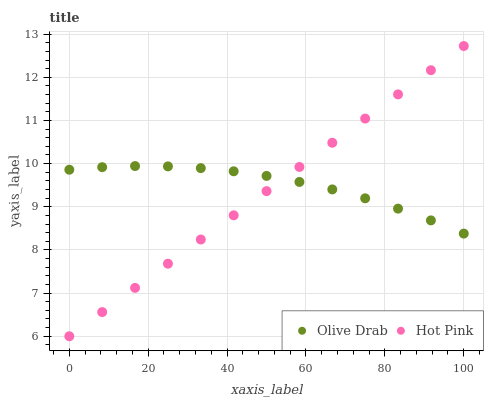Does Hot Pink have the minimum area under the curve?
Answer yes or no. Yes. Does Olive Drab have the maximum area under the curve?
Answer yes or no. Yes. Does Olive Drab have the minimum area under the curve?
Answer yes or no. No. Is Hot Pink the smoothest?
Answer yes or no. Yes. Is Olive Drab the roughest?
Answer yes or no. Yes. Is Olive Drab the smoothest?
Answer yes or no. No. Does Hot Pink have the lowest value?
Answer yes or no. Yes. Does Olive Drab have the lowest value?
Answer yes or no. No. Does Hot Pink have the highest value?
Answer yes or no. Yes. Does Olive Drab have the highest value?
Answer yes or no. No. Does Olive Drab intersect Hot Pink?
Answer yes or no. Yes. Is Olive Drab less than Hot Pink?
Answer yes or no. No. Is Olive Drab greater than Hot Pink?
Answer yes or no. No. 